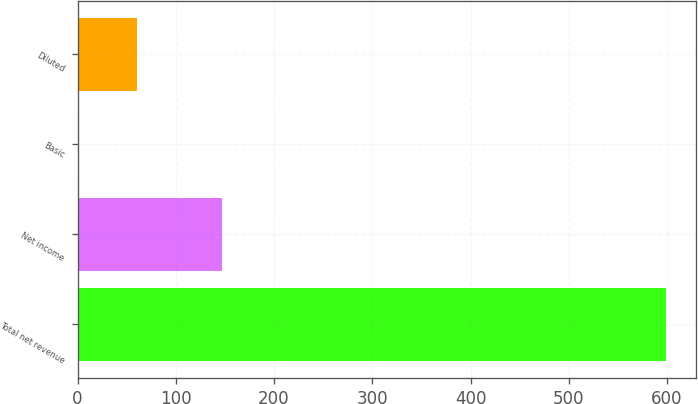<chart> <loc_0><loc_0><loc_500><loc_500><bar_chart><fcel>Total net revenue<fcel>Net income<fcel>Basic<fcel>Diluted<nl><fcel>599<fcel>147<fcel>0.49<fcel>60.34<nl></chart> 